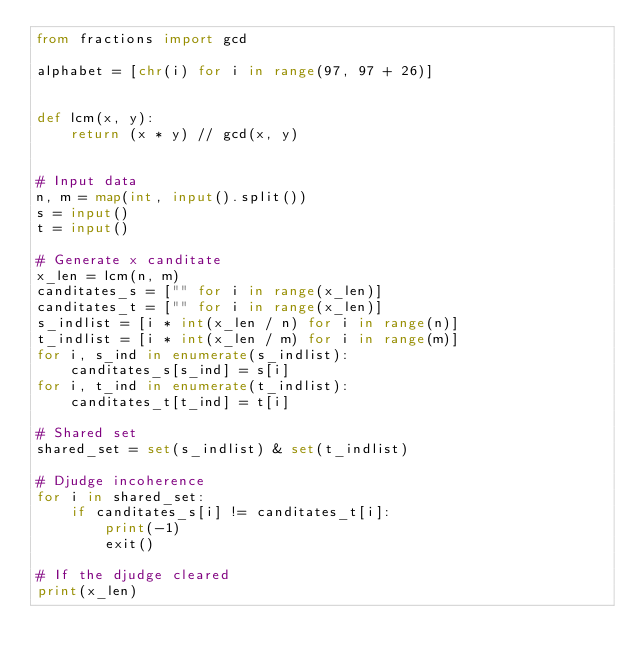Convert code to text. <code><loc_0><loc_0><loc_500><loc_500><_Python_>from fractions import gcd

alphabet = [chr(i) for i in range(97, 97 + 26)]


def lcm(x, y):
    return (x * y) // gcd(x, y)


# Input data
n, m = map(int, input().split())
s = input()
t = input()

# Generate x canditate
x_len = lcm(n, m)
canditates_s = ["" for i in range(x_len)]
canditates_t = ["" for i in range(x_len)]
s_indlist = [i * int(x_len / n) for i in range(n)]
t_indlist = [i * int(x_len / m) for i in range(m)]
for i, s_ind in enumerate(s_indlist):
    canditates_s[s_ind] = s[i]
for i, t_ind in enumerate(t_indlist):
    canditates_t[t_ind] = t[i]

# Shared set
shared_set = set(s_indlist) & set(t_indlist)
    
# Djudge incoherence
for i in shared_set:
    if canditates_s[i] != canditates_t[i]:
        print(-1)
        exit()

# If the djudge cleared
print(x_len)</code> 